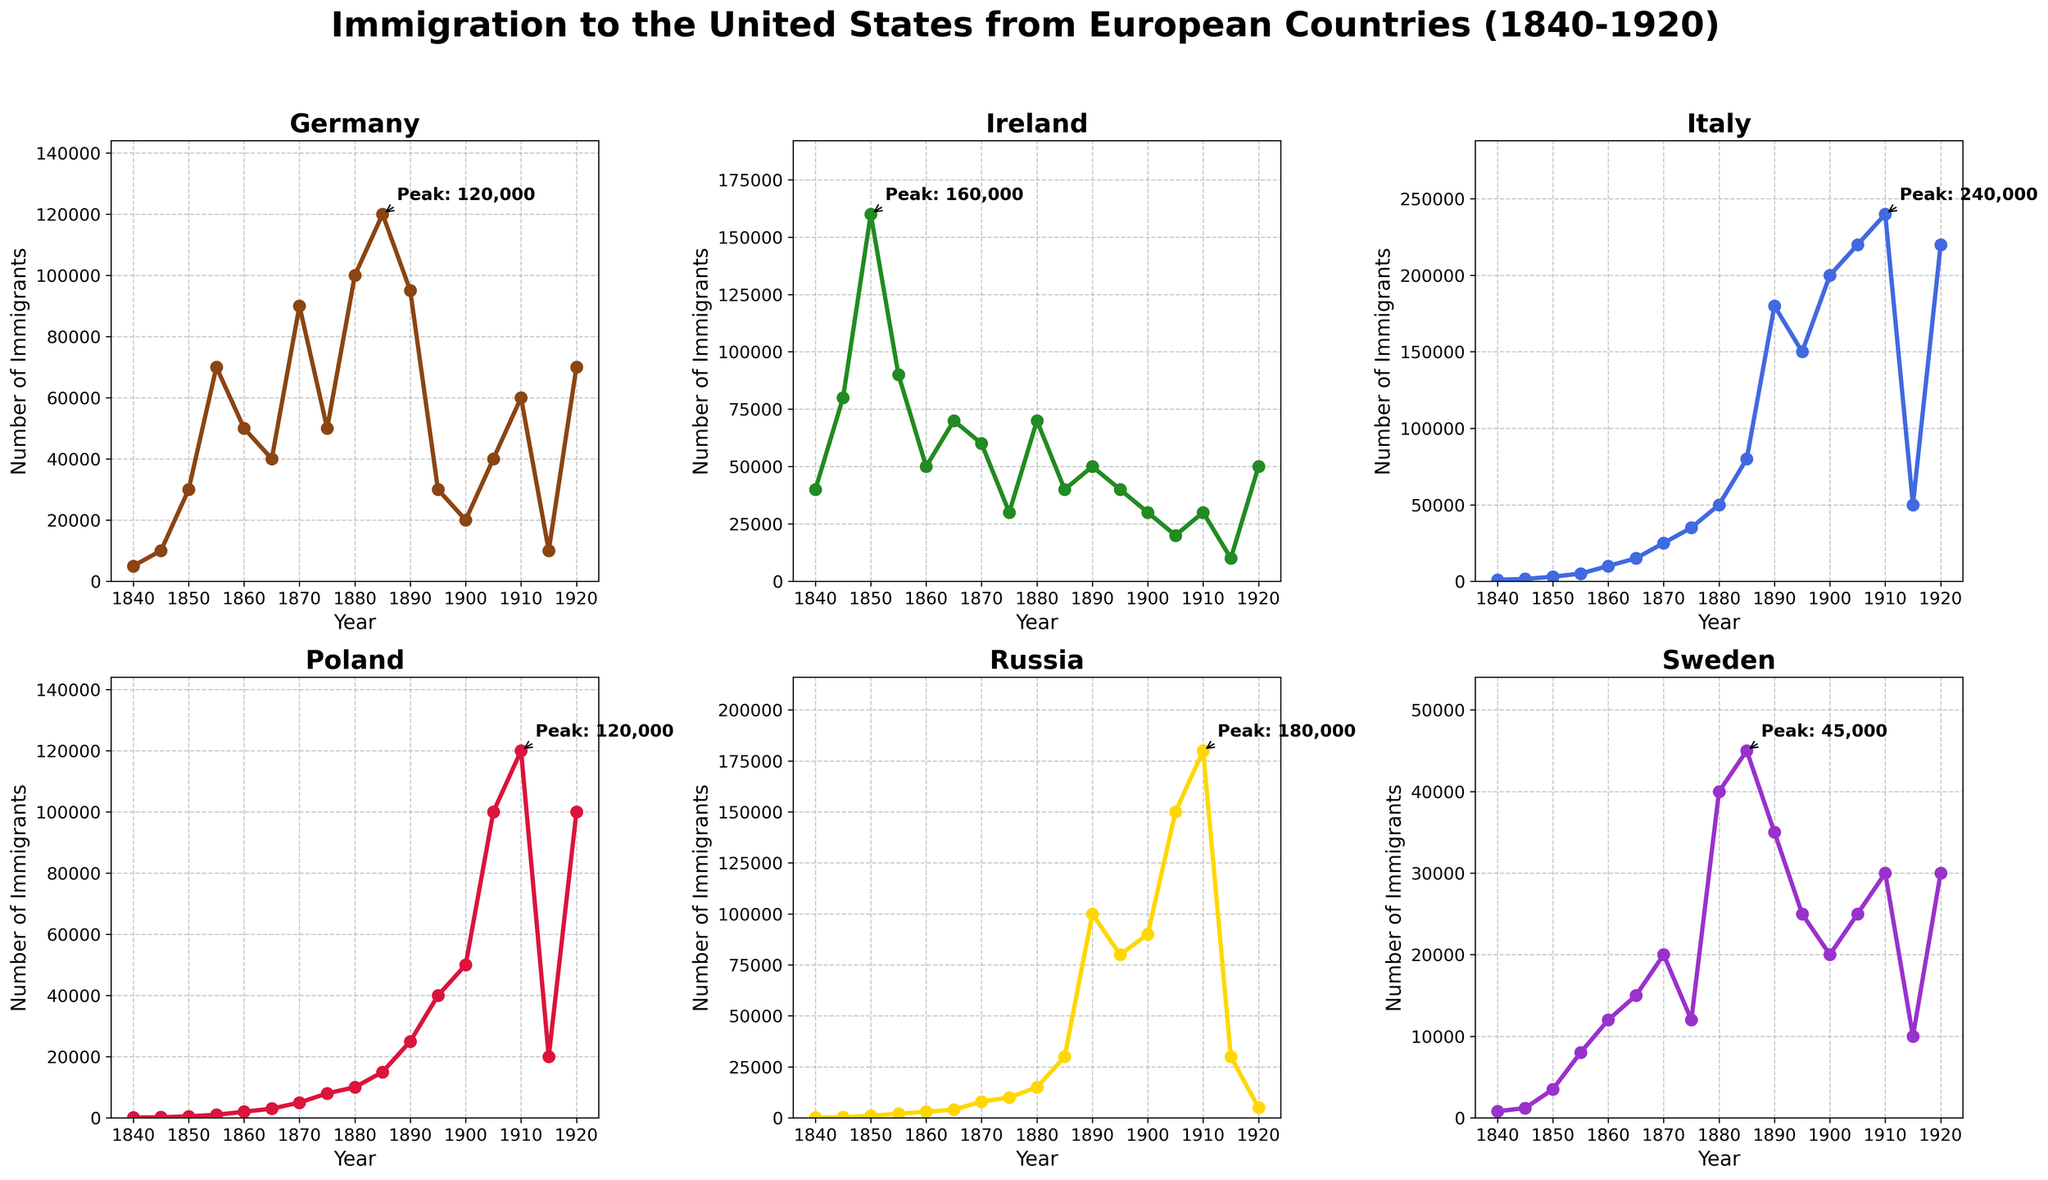Which country had the highest peak of immigration to the United States between 1840 and 1920? The visual inspection of the subplots shows that Russia has the highest peak value annotated, which is 180,000 immigrants around 1910. Other countries' peaks are lower in comparison.
Answer: Russia In what year did Italy experience its peak immigration to the United States, and what was the number? Looking at Italy's subplot, the peak value annotation points to the year 1910, with a peak immigration number of 240,000.
Answer: 1910, 240,000 How does the peak immigration number from Germany compare to that from Sweden? By comparing the annotated peaks, Germany's highest peak is around 120,000 immigrants, whereas Sweden's is around 40,000 immigrants. Thus, Germany's peak is higher than Sweden's.
Answer: Germany's peak is higher Calculate the average number of immigrants from Poland during the 5-year peak period around 1910. The 5-year period around Poland's peak (1910) includes 1895, 1900, 1905, 1910, and 1915. The immigration numbers are 25,000, 50,000, 100,000, 120,000, and 20,000 respectively. Adding these gives 315,000; dividing by 5 gives an average of 63,000.
Answer: 63,000 Which two countries had the most significant decrease in the number of immigrants immediately following their peak years? By examining the subplots, it is apparent that both Russia and Italy had significant decreases. Russia's peak at 1910 was 180,000, which dropped to 5,000 by 1920. Italy's peak at 1910 was 240,000, which dropped to 50,000 by 1915. These are the most significant decreases post-peak.
Answer: Russia and Italy What are the immigration trends for Ireland during the periods of 1840-1855 and 1860-1870? For the period from 1840-1855, Ireland shows an increase in immigrants rising from 40,000 to 160,000. For 1860-1870, Irish immigration shows a decrease from 50,000 to 60,000.
Answer: Increase in 1840-1855, Decrease in 1860-1870 How many total immigrants came from Germany between 1880 and 1920? Summing the number of immigrants from Germany in 1880, 1885, 1890, 1895, 1900, 1905, 1910, 1915, and 1920: 100,000 + 120,000 + 95,000 + 30,000 + 20,000 + 40,000 + 60,000 + 10,000 + 70,000 = 545,000.
Answer: 545,000 Which country shows a more consistent trend of immigration over the years, and how can it be interpreted from the subplot? Reviewing the subplots, Ireland shows the most consistent trend without extreme peaks or troughs. This consistency indicates stable immigration patterns compared to more volatile trends in other countries.
Answer: Ireland 